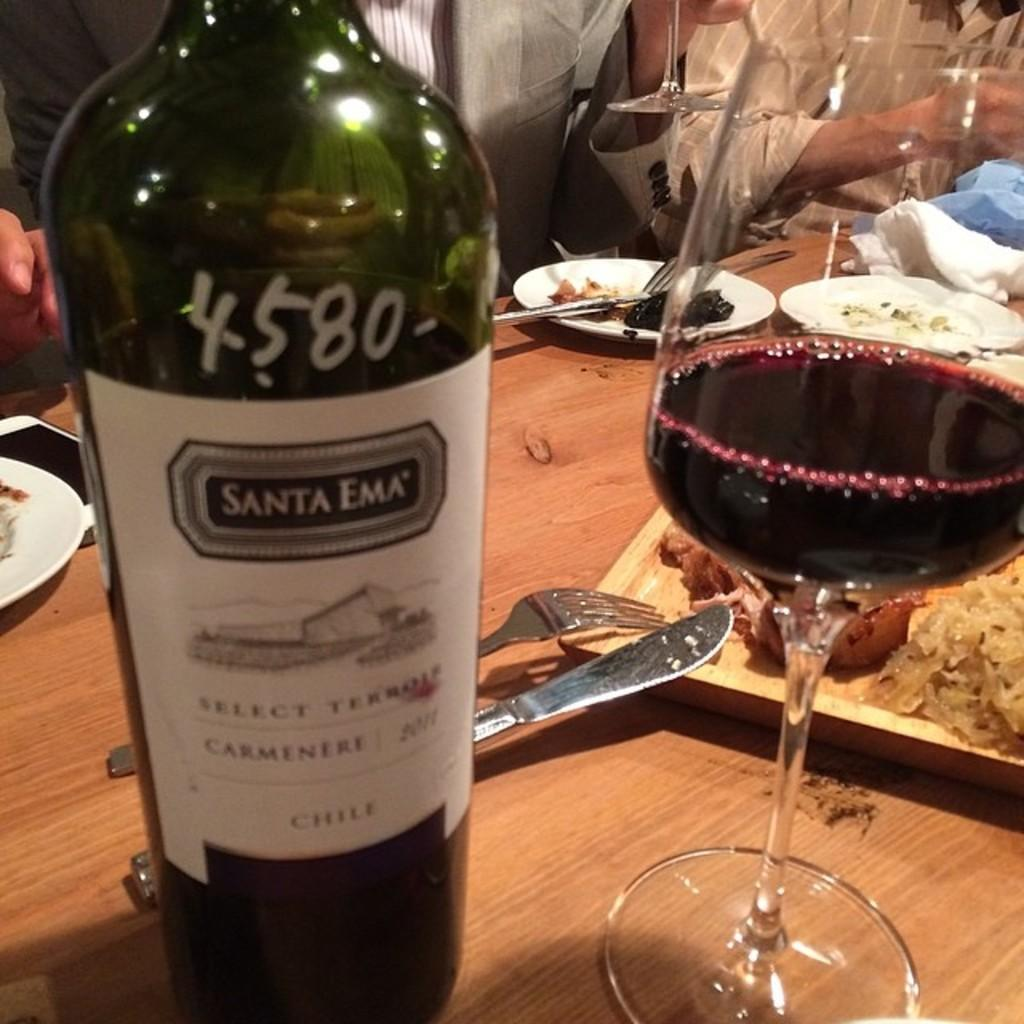<image>
Present a compact description of the photo's key features. A bottle of Santa Ema wine is poured into a glass next to it. 